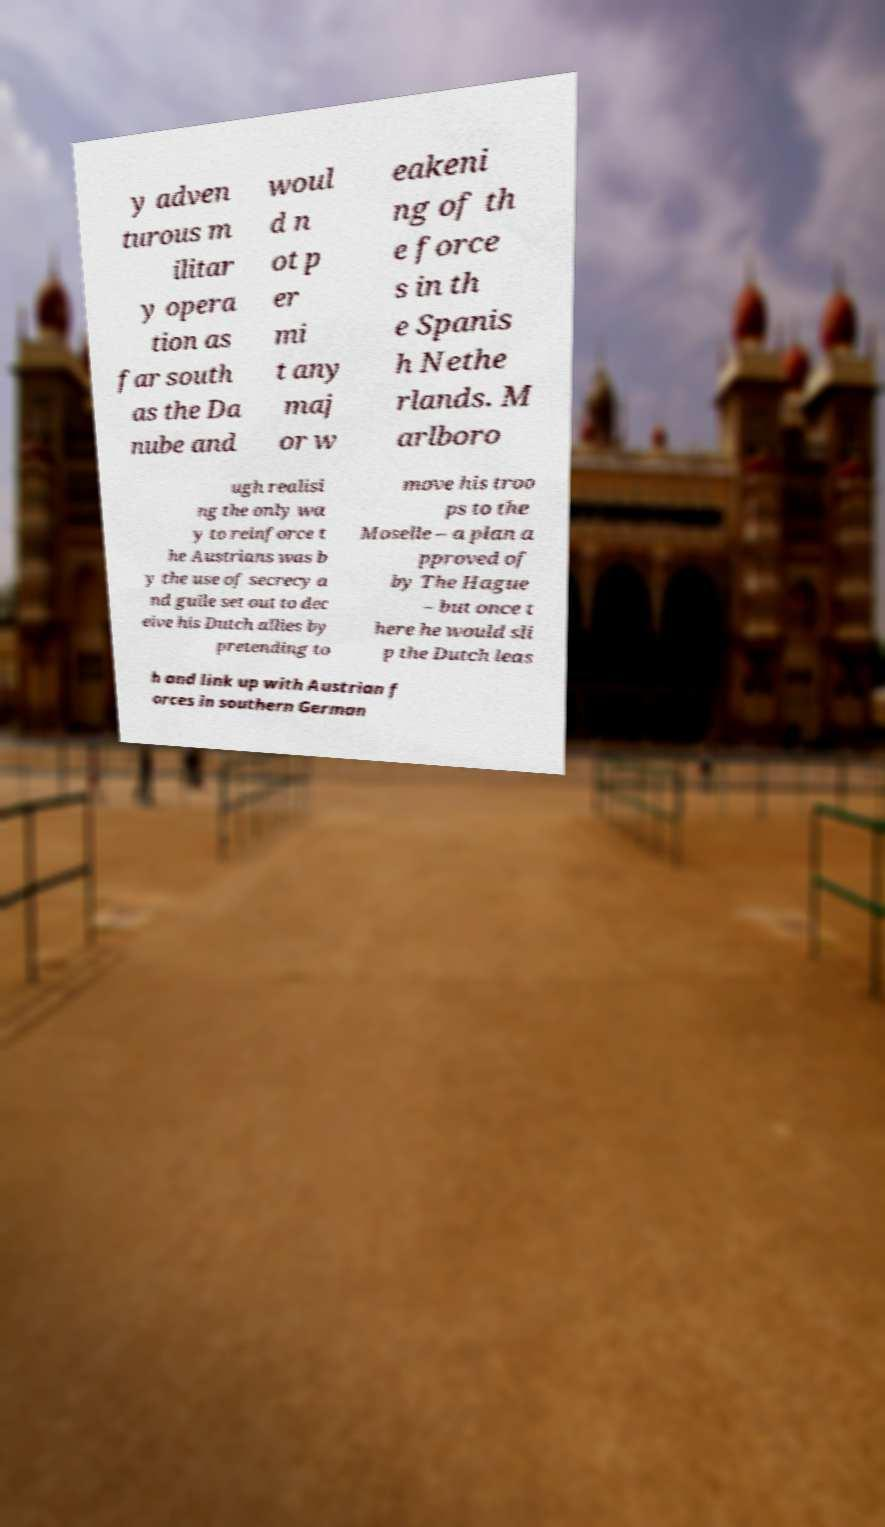I need the written content from this picture converted into text. Can you do that? y adven turous m ilitar y opera tion as far south as the Da nube and woul d n ot p er mi t any maj or w eakeni ng of th e force s in th e Spanis h Nethe rlands. M arlboro ugh realisi ng the only wa y to reinforce t he Austrians was b y the use of secrecy a nd guile set out to dec eive his Dutch allies by pretending to move his troo ps to the Moselle – a plan a pproved of by The Hague – but once t here he would sli p the Dutch leas h and link up with Austrian f orces in southern German 